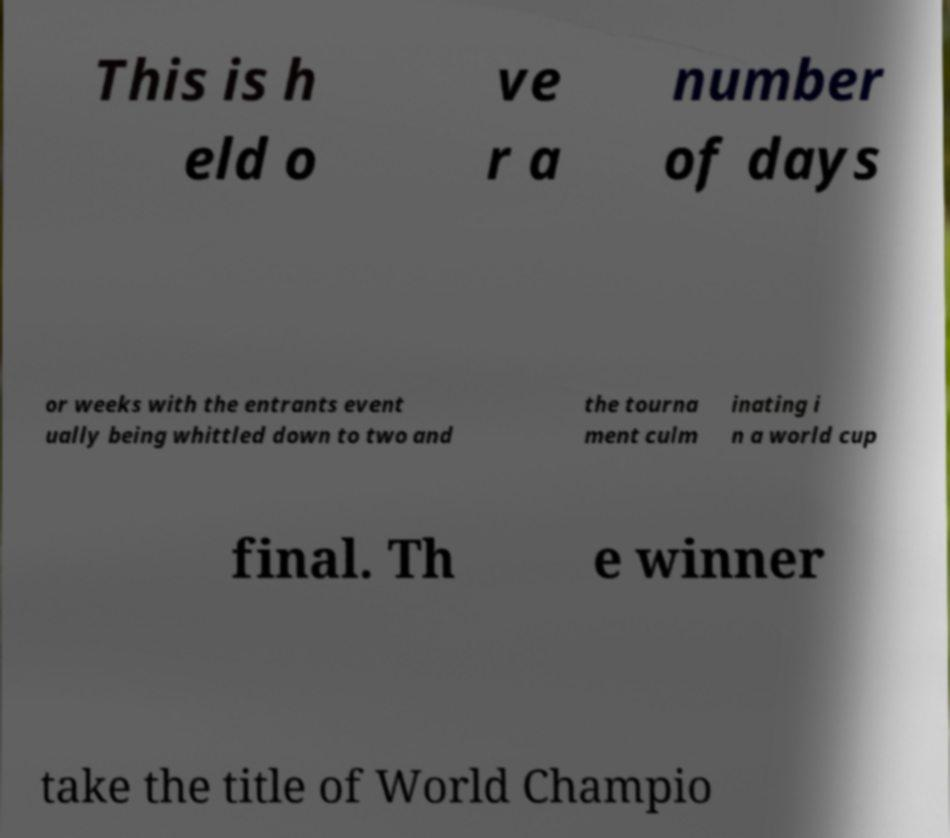There's text embedded in this image that I need extracted. Can you transcribe it verbatim? This is h eld o ve r a number of days or weeks with the entrants event ually being whittled down to two and the tourna ment culm inating i n a world cup final. Th e winner take the title of World Champio 